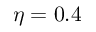<formula> <loc_0><loc_0><loc_500><loc_500>\eta = 0 . 4</formula> 